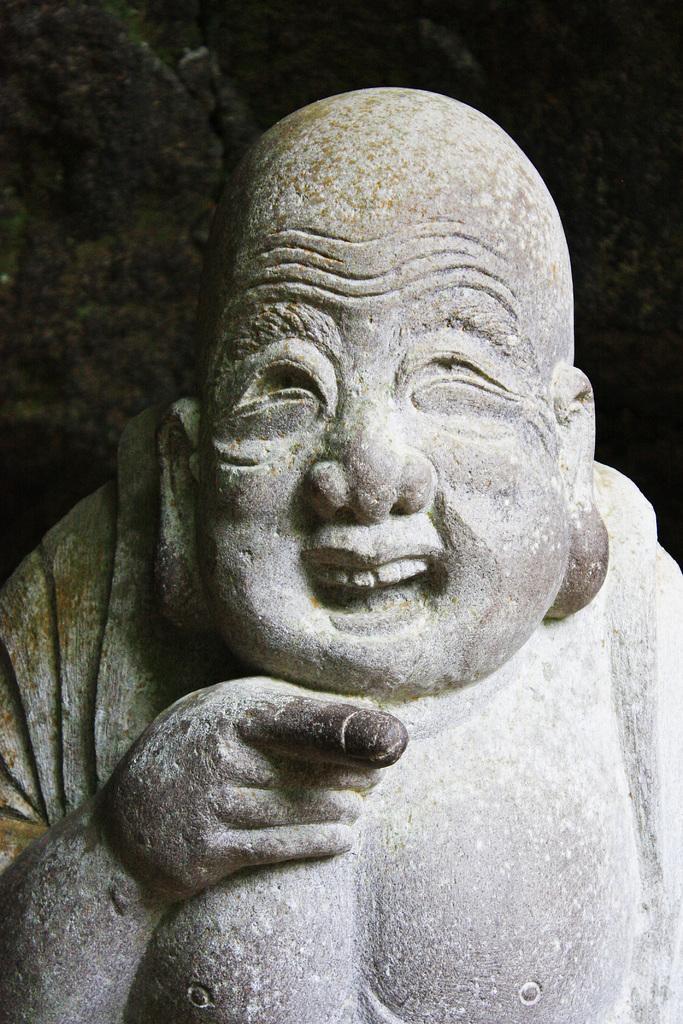Please provide a concise description of this image. This image consists of a statue made up of rock. 